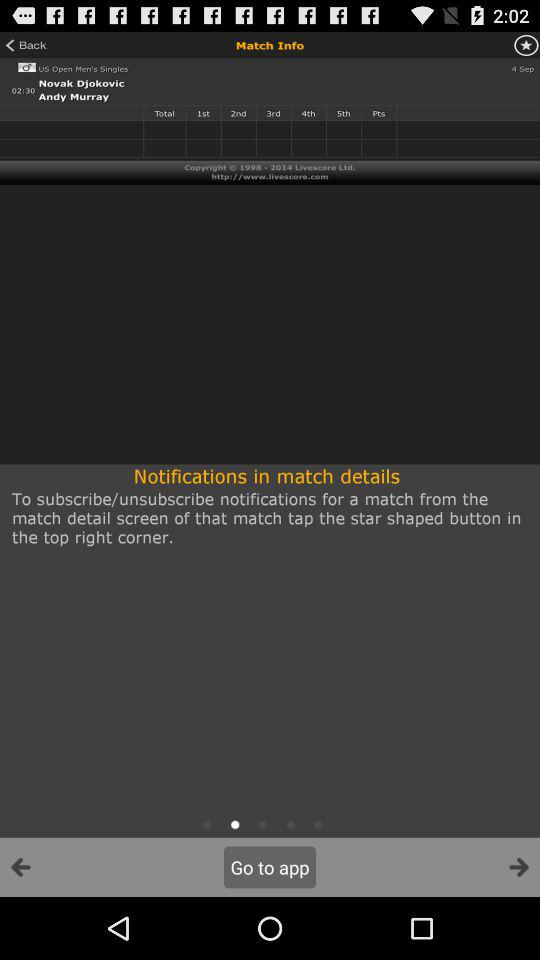What is the time of Novak Djokovic and Andy Murray match? The time is 02:30. 